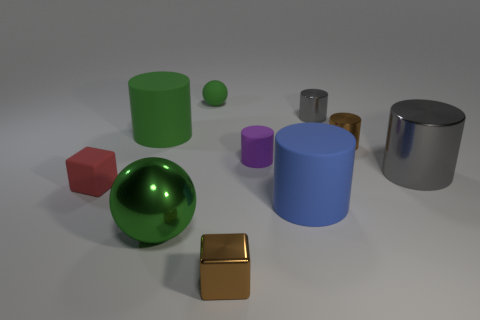Do the shiny sphere and the tiny rubber ball have the same color?
Provide a succinct answer. Yes. Is there any other thing that is the same color as the large metal ball?
Keep it short and to the point. Yes. Does the ball that is behind the tiny rubber cylinder have the same color as the big object that is behind the large gray shiny object?
Provide a succinct answer. Yes. What number of things have the same color as the rubber sphere?
Your answer should be very brief. 2. Are there more small metallic cylinders that are behind the small red object than matte cylinders right of the tiny purple matte cylinder?
Keep it short and to the point. Yes. What is the size of the matte cylinder that is the same color as the metal sphere?
Your response must be concise. Large. Do the brown metal cube and the ball behind the blue matte object have the same size?
Your response must be concise. Yes. How many blocks are green rubber things or large objects?
Provide a succinct answer. 0. What is the size of the green sphere that is the same material as the red object?
Provide a succinct answer. Small. There is a brown metallic object that is behind the red matte thing; does it have the same size as the gray cylinder that is behind the purple cylinder?
Provide a succinct answer. Yes. 